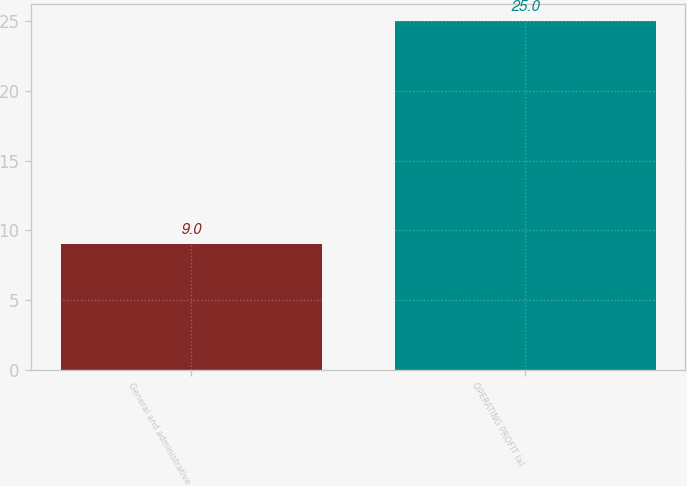Convert chart. <chart><loc_0><loc_0><loc_500><loc_500><bar_chart><fcel>General and administrative<fcel>OPERATING PROFIT (a)<nl><fcel>9<fcel>25<nl></chart> 